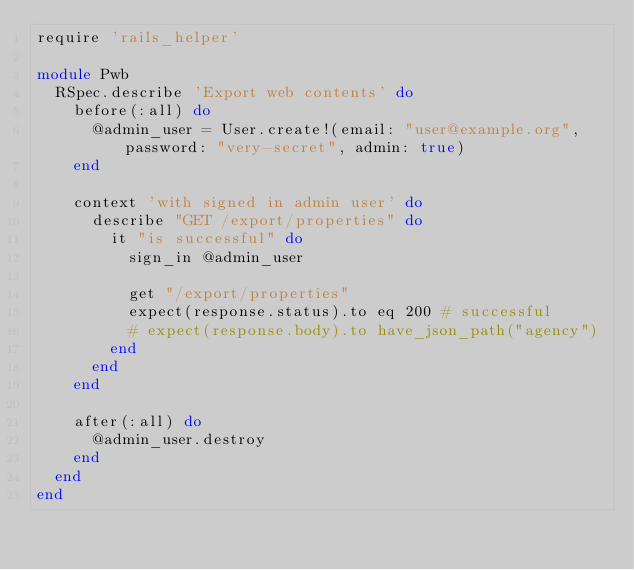<code> <loc_0><loc_0><loc_500><loc_500><_Ruby_>require 'rails_helper'

module Pwb
  RSpec.describe 'Export web contents' do
    before(:all) do
      @admin_user = User.create!(email: "user@example.org", password: "very-secret", admin: true)
    end

    context 'with signed in admin user' do
      describe "GET /export/properties" do
        it "is successful" do
          sign_in @admin_user

          get "/export/properties"
          expect(response.status).to eq 200 # successful
          # expect(response.body).to have_json_path("agency")
        end
      end
    end

    after(:all) do
      @admin_user.destroy
    end
  end
end
</code> 